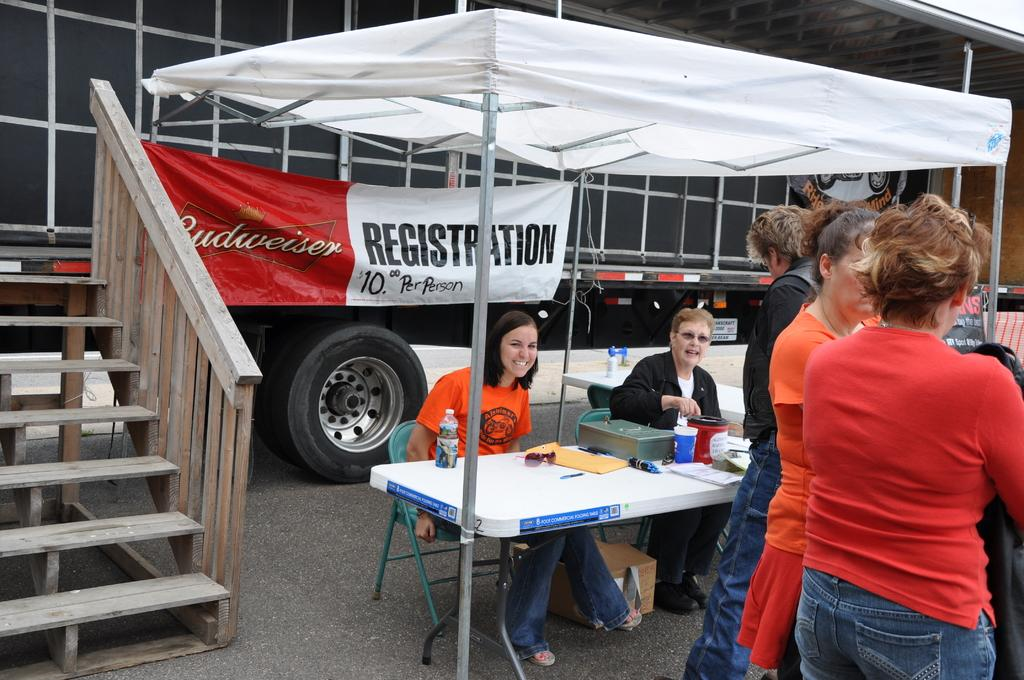How many people are standing on the right side of the image? There are three persons standing on the right side of the image. What are the women in the image doing? The women are sitting on a chair in the image. What is the facial expression of the women? The women are smiling. What can be seen in the background of the image? Wheels are visible in the background of the image. What type of sheet is being used by the women to generate income in the image? There is no sheet or income-generating activity depicted in the image; it simply shows three persons standing and two women sitting and smiling. 